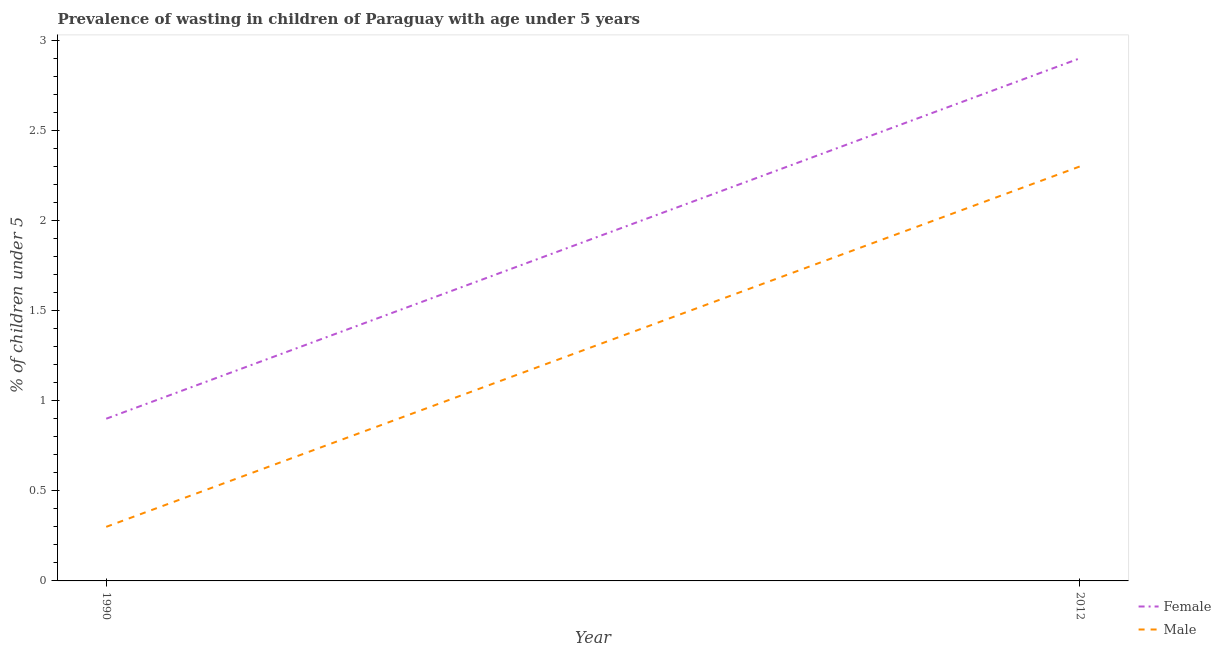How many different coloured lines are there?
Make the answer very short. 2. Is the number of lines equal to the number of legend labels?
Ensure brevity in your answer.  Yes. What is the percentage of undernourished male children in 2012?
Make the answer very short. 2.3. Across all years, what is the maximum percentage of undernourished male children?
Offer a very short reply. 2.3. Across all years, what is the minimum percentage of undernourished female children?
Your answer should be compact. 0.9. What is the total percentage of undernourished male children in the graph?
Offer a terse response. 2.6. What is the difference between the percentage of undernourished female children in 1990 and that in 2012?
Ensure brevity in your answer.  -2. What is the difference between the percentage of undernourished male children in 2012 and the percentage of undernourished female children in 1990?
Your answer should be compact. 1.4. What is the average percentage of undernourished male children per year?
Keep it short and to the point. 1.3. In the year 2012, what is the difference between the percentage of undernourished female children and percentage of undernourished male children?
Keep it short and to the point. 0.6. In how many years, is the percentage of undernourished female children greater than 0.4 %?
Your response must be concise. 2. What is the ratio of the percentage of undernourished female children in 1990 to that in 2012?
Your answer should be compact. 0.31. Is the percentage of undernourished male children in 1990 less than that in 2012?
Ensure brevity in your answer.  Yes. How many lines are there?
Your answer should be very brief. 2. How many years are there in the graph?
Keep it short and to the point. 2. Does the graph contain grids?
Offer a terse response. No. Where does the legend appear in the graph?
Offer a terse response. Bottom right. How many legend labels are there?
Make the answer very short. 2. How are the legend labels stacked?
Your response must be concise. Vertical. What is the title of the graph?
Your answer should be very brief. Prevalence of wasting in children of Paraguay with age under 5 years. Does "Girls" appear as one of the legend labels in the graph?
Provide a succinct answer. No. What is the label or title of the X-axis?
Provide a short and direct response. Year. What is the label or title of the Y-axis?
Provide a succinct answer.  % of children under 5. What is the  % of children under 5 of Female in 1990?
Your response must be concise. 0.9. What is the  % of children under 5 of Male in 1990?
Provide a succinct answer. 0.3. What is the  % of children under 5 in Female in 2012?
Offer a terse response. 2.9. What is the  % of children under 5 of Male in 2012?
Give a very brief answer. 2.3. Across all years, what is the maximum  % of children under 5 of Female?
Make the answer very short. 2.9. Across all years, what is the maximum  % of children under 5 of Male?
Make the answer very short. 2.3. Across all years, what is the minimum  % of children under 5 in Female?
Your answer should be very brief. 0.9. Across all years, what is the minimum  % of children under 5 in Male?
Ensure brevity in your answer.  0.3. What is the total  % of children under 5 in Female in the graph?
Your answer should be very brief. 3.8. What is the total  % of children under 5 in Male in the graph?
Ensure brevity in your answer.  2.6. What is the difference between the  % of children under 5 in Female in 1990 and that in 2012?
Give a very brief answer. -2. What is the difference between the  % of children under 5 in Female in 1990 and the  % of children under 5 in Male in 2012?
Offer a very short reply. -1.4. What is the average  % of children under 5 of Female per year?
Keep it short and to the point. 1.9. In the year 2012, what is the difference between the  % of children under 5 in Female and  % of children under 5 in Male?
Offer a very short reply. 0.6. What is the ratio of the  % of children under 5 of Female in 1990 to that in 2012?
Provide a succinct answer. 0.31. What is the ratio of the  % of children under 5 in Male in 1990 to that in 2012?
Provide a short and direct response. 0.13. What is the difference between the highest and the second highest  % of children under 5 in Female?
Give a very brief answer. 2. What is the difference between the highest and the second highest  % of children under 5 in Male?
Ensure brevity in your answer.  2. What is the difference between the highest and the lowest  % of children under 5 of Male?
Keep it short and to the point. 2. 